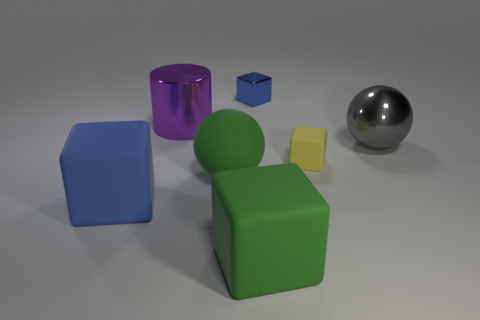Add 3 green blocks. How many objects exist? 10 Subtract all cylinders. How many objects are left? 6 Subtract all large blue objects. Subtract all gray shiny balls. How many objects are left? 5 Add 2 small blocks. How many small blocks are left? 4 Add 6 purple shiny cubes. How many purple shiny cubes exist? 6 Subtract 0 brown balls. How many objects are left? 7 